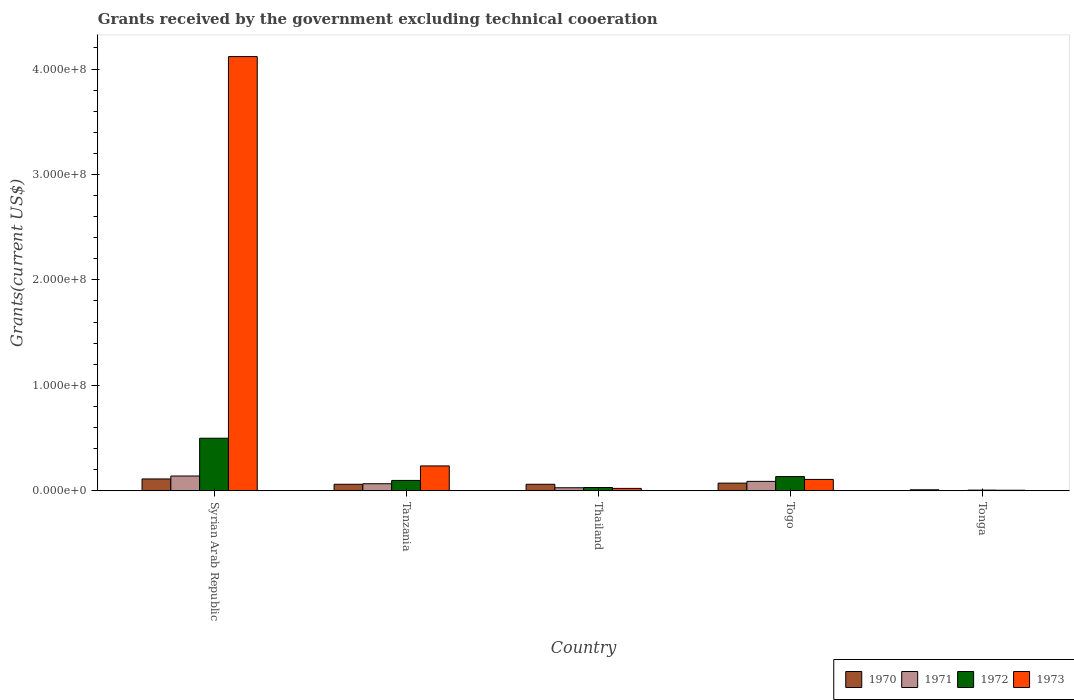How many bars are there on the 1st tick from the right?
Provide a short and direct response. 4. What is the label of the 4th group of bars from the left?
Keep it short and to the point. Togo. What is the total grants received by the government in 1970 in Thailand?
Your answer should be compact. 6.18e+06. Across all countries, what is the maximum total grants received by the government in 1972?
Provide a succinct answer. 4.98e+07. Across all countries, what is the minimum total grants received by the government in 1970?
Provide a succinct answer. 9.50e+05. In which country was the total grants received by the government in 1972 maximum?
Your response must be concise. Syrian Arab Republic. In which country was the total grants received by the government in 1970 minimum?
Your answer should be compact. Tonga. What is the total total grants received by the government in 1972 in the graph?
Provide a short and direct response. 7.69e+07. What is the difference between the total grants received by the government in 1971 in Tanzania and that in Togo?
Give a very brief answer. -2.25e+06. What is the difference between the total grants received by the government in 1972 in Tanzania and the total grants received by the government in 1973 in Thailand?
Provide a succinct answer. 7.55e+06. What is the average total grants received by the government in 1972 per country?
Provide a succinct answer. 1.54e+07. What is the difference between the total grants received by the government of/in 1972 and total grants received by the government of/in 1973 in Tanzania?
Your answer should be compact. -1.38e+07. In how many countries, is the total grants received by the government in 1971 greater than 200000000 US$?
Make the answer very short. 0. What is the ratio of the total grants received by the government in 1971 in Thailand to that in Togo?
Keep it short and to the point. 0.32. Is the difference between the total grants received by the government in 1972 in Thailand and Togo greater than the difference between the total grants received by the government in 1973 in Thailand and Togo?
Give a very brief answer. No. What is the difference between the highest and the second highest total grants received by the government in 1972?
Make the answer very short. 3.64e+07. What is the difference between the highest and the lowest total grants received by the government in 1973?
Make the answer very short. 4.11e+08. Is it the case that in every country, the sum of the total grants received by the government in 1973 and total grants received by the government in 1972 is greater than the sum of total grants received by the government in 1971 and total grants received by the government in 1970?
Provide a succinct answer. No. What does the 4th bar from the left in Syrian Arab Republic represents?
Your response must be concise. 1973. What does the 2nd bar from the right in Tonga represents?
Provide a succinct answer. 1972. Is it the case that in every country, the sum of the total grants received by the government in 1971 and total grants received by the government in 1970 is greater than the total grants received by the government in 1972?
Keep it short and to the point. No. How many bars are there?
Provide a succinct answer. 20. Are all the bars in the graph horizontal?
Make the answer very short. No. How many countries are there in the graph?
Your response must be concise. 5. Are the values on the major ticks of Y-axis written in scientific E-notation?
Keep it short and to the point. Yes. How are the legend labels stacked?
Your answer should be compact. Horizontal. What is the title of the graph?
Your answer should be compact. Grants received by the government excluding technical cooeration. What is the label or title of the X-axis?
Provide a short and direct response. Country. What is the label or title of the Y-axis?
Provide a short and direct response. Grants(current US$). What is the Grants(current US$) in 1970 in Syrian Arab Republic?
Give a very brief answer. 1.12e+07. What is the Grants(current US$) in 1971 in Syrian Arab Republic?
Your answer should be very brief. 1.40e+07. What is the Grants(current US$) of 1972 in Syrian Arab Republic?
Keep it short and to the point. 4.98e+07. What is the Grants(current US$) in 1973 in Syrian Arab Republic?
Your answer should be very brief. 4.12e+08. What is the Grants(current US$) of 1970 in Tanzania?
Ensure brevity in your answer.  6.17e+06. What is the Grants(current US$) in 1971 in Tanzania?
Give a very brief answer. 6.68e+06. What is the Grants(current US$) of 1972 in Tanzania?
Offer a very short reply. 9.82e+06. What is the Grants(current US$) in 1973 in Tanzania?
Your response must be concise. 2.36e+07. What is the Grants(current US$) in 1970 in Thailand?
Your response must be concise. 6.18e+06. What is the Grants(current US$) of 1971 in Thailand?
Your answer should be very brief. 2.88e+06. What is the Grants(current US$) of 1972 in Thailand?
Your response must be concise. 3.12e+06. What is the Grants(current US$) in 1973 in Thailand?
Your answer should be very brief. 2.27e+06. What is the Grants(current US$) in 1970 in Togo?
Provide a short and direct response. 7.26e+06. What is the Grants(current US$) of 1971 in Togo?
Your answer should be very brief. 8.93e+06. What is the Grants(current US$) in 1972 in Togo?
Your answer should be compact. 1.35e+07. What is the Grants(current US$) of 1973 in Togo?
Give a very brief answer. 1.08e+07. What is the Grants(current US$) in 1970 in Tonga?
Your answer should be very brief. 9.50e+05. What is the Grants(current US$) in 1972 in Tonga?
Offer a very short reply. 6.30e+05. What is the Grants(current US$) of 1973 in Tonga?
Provide a short and direct response. 5.10e+05. Across all countries, what is the maximum Grants(current US$) in 1970?
Give a very brief answer. 1.12e+07. Across all countries, what is the maximum Grants(current US$) of 1971?
Provide a succinct answer. 1.40e+07. Across all countries, what is the maximum Grants(current US$) in 1972?
Give a very brief answer. 4.98e+07. Across all countries, what is the maximum Grants(current US$) in 1973?
Provide a short and direct response. 4.12e+08. Across all countries, what is the minimum Grants(current US$) in 1970?
Provide a short and direct response. 9.50e+05. Across all countries, what is the minimum Grants(current US$) in 1972?
Make the answer very short. 6.30e+05. Across all countries, what is the minimum Grants(current US$) in 1973?
Your response must be concise. 5.10e+05. What is the total Grants(current US$) of 1970 in the graph?
Make the answer very short. 3.18e+07. What is the total Grants(current US$) of 1971 in the graph?
Offer a terse response. 3.28e+07. What is the total Grants(current US$) in 1972 in the graph?
Offer a very short reply. 7.69e+07. What is the total Grants(current US$) of 1973 in the graph?
Offer a terse response. 4.49e+08. What is the difference between the Grants(current US$) in 1970 in Syrian Arab Republic and that in Tanzania?
Provide a succinct answer. 5.06e+06. What is the difference between the Grants(current US$) of 1971 in Syrian Arab Republic and that in Tanzania?
Your answer should be very brief. 7.33e+06. What is the difference between the Grants(current US$) of 1972 in Syrian Arab Republic and that in Tanzania?
Your answer should be compact. 4.00e+07. What is the difference between the Grants(current US$) of 1973 in Syrian Arab Republic and that in Tanzania?
Offer a terse response. 3.88e+08. What is the difference between the Grants(current US$) of 1970 in Syrian Arab Republic and that in Thailand?
Your answer should be very brief. 5.05e+06. What is the difference between the Grants(current US$) in 1971 in Syrian Arab Republic and that in Thailand?
Offer a terse response. 1.11e+07. What is the difference between the Grants(current US$) of 1972 in Syrian Arab Republic and that in Thailand?
Give a very brief answer. 4.67e+07. What is the difference between the Grants(current US$) in 1973 in Syrian Arab Republic and that in Thailand?
Provide a short and direct response. 4.10e+08. What is the difference between the Grants(current US$) of 1970 in Syrian Arab Republic and that in Togo?
Give a very brief answer. 3.97e+06. What is the difference between the Grants(current US$) of 1971 in Syrian Arab Republic and that in Togo?
Provide a short and direct response. 5.08e+06. What is the difference between the Grants(current US$) of 1972 in Syrian Arab Republic and that in Togo?
Keep it short and to the point. 3.64e+07. What is the difference between the Grants(current US$) of 1973 in Syrian Arab Republic and that in Togo?
Provide a succinct answer. 4.01e+08. What is the difference between the Grants(current US$) in 1970 in Syrian Arab Republic and that in Tonga?
Your answer should be very brief. 1.03e+07. What is the difference between the Grants(current US$) in 1971 in Syrian Arab Republic and that in Tonga?
Provide a succinct answer. 1.38e+07. What is the difference between the Grants(current US$) in 1972 in Syrian Arab Republic and that in Tonga?
Provide a short and direct response. 4.92e+07. What is the difference between the Grants(current US$) of 1973 in Syrian Arab Republic and that in Tonga?
Keep it short and to the point. 4.11e+08. What is the difference between the Grants(current US$) of 1970 in Tanzania and that in Thailand?
Your answer should be very brief. -10000. What is the difference between the Grants(current US$) in 1971 in Tanzania and that in Thailand?
Offer a terse response. 3.80e+06. What is the difference between the Grants(current US$) in 1972 in Tanzania and that in Thailand?
Give a very brief answer. 6.70e+06. What is the difference between the Grants(current US$) of 1973 in Tanzania and that in Thailand?
Ensure brevity in your answer.  2.13e+07. What is the difference between the Grants(current US$) of 1970 in Tanzania and that in Togo?
Provide a succinct answer. -1.09e+06. What is the difference between the Grants(current US$) in 1971 in Tanzania and that in Togo?
Offer a very short reply. -2.25e+06. What is the difference between the Grants(current US$) of 1972 in Tanzania and that in Togo?
Your response must be concise. -3.66e+06. What is the difference between the Grants(current US$) in 1973 in Tanzania and that in Togo?
Keep it short and to the point. 1.28e+07. What is the difference between the Grants(current US$) in 1970 in Tanzania and that in Tonga?
Offer a terse response. 5.22e+06. What is the difference between the Grants(current US$) of 1971 in Tanzania and that in Tonga?
Make the answer very short. 6.42e+06. What is the difference between the Grants(current US$) of 1972 in Tanzania and that in Tonga?
Offer a very short reply. 9.19e+06. What is the difference between the Grants(current US$) in 1973 in Tanzania and that in Tonga?
Your answer should be compact. 2.31e+07. What is the difference between the Grants(current US$) of 1970 in Thailand and that in Togo?
Your answer should be compact. -1.08e+06. What is the difference between the Grants(current US$) in 1971 in Thailand and that in Togo?
Make the answer very short. -6.05e+06. What is the difference between the Grants(current US$) of 1972 in Thailand and that in Togo?
Make the answer very short. -1.04e+07. What is the difference between the Grants(current US$) of 1973 in Thailand and that in Togo?
Your response must be concise. -8.52e+06. What is the difference between the Grants(current US$) in 1970 in Thailand and that in Tonga?
Your answer should be compact. 5.23e+06. What is the difference between the Grants(current US$) in 1971 in Thailand and that in Tonga?
Provide a succinct answer. 2.62e+06. What is the difference between the Grants(current US$) in 1972 in Thailand and that in Tonga?
Provide a short and direct response. 2.49e+06. What is the difference between the Grants(current US$) in 1973 in Thailand and that in Tonga?
Keep it short and to the point. 1.76e+06. What is the difference between the Grants(current US$) in 1970 in Togo and that in Tonga?
Keep it short and to the point. 6.31e+06. What is the difference between the Grants(current US$) in 1971 in Togo and that in Tonga?
Keep it short and to the point. 8.67e+06. What is the difference between the Grants(current US$) in 1972 in Togo and that in Tonga?
Your response must be concise. 1.28e+07. What is the difference between the Grants(current US$) of 1973 in Togo and that in Tonga?
Keep it short and to the point. 1.03e+07. What is the difference between the Grants(current US$) of 1970 in Syrian Arab Republic and the Grants(current US$) of 1971 in Tanzania?
Offer a terse response. 4.55e+06. What is the difference between the Grants(current US$) in 1970 in Syrian Arab Republic and the Grants(current US$) in 1972 in Tanzania?
Provide a short and direct response. 1.41e+06. What is the difference between the Grants(current US$) of 1970 in Syrian Arab Republic and the Grants(current US$) of 1973 in Tanzania?
Provide a succinct answer. -1.24e+07. What is the difference between the Grants(current US$) in 1971 in Syrian Arab Republic and the Grants(current US$) in 1972 in Tanzania?
Your answer should be compact. 4.19e+06. What is the difference between the Grants(current US$) of 1971 in Syrian Arab Republic and the Grants(current US$) of 1973 in Tanzania?
Provide a short and direct response. -9.57e+06. What is the difference between the Grants(current US$) in 1972 in Syrian Arab Republic and the Grants(current US$) in 1973 in Tanzania?
Provide a short and direct response. 2.63e+07. What is the difference between the Grants(current US$) in 1970 in Syrian Arab Republic and the Grants(current US$) in 1971 in Thailand?
Your answer should be compact. 8.35e+06. What is the difference between the Grants(current US$) of 1970 in Syrian Arab Republic and the Grants(current US$) of 1972 in Thailand?
Provide a short and direct response. 8.11e+06. What is the difference between the Grants(current US$) of 1970 in Syrian Arab Republic and the Grants(current US$) of 1973 in Thailand?
Provide a succinct answer. 8.96e+06. What is the difference between the Grants(current US$) in 1971 in Syrian Arab Republic and the Grants(current US$) in 1972 in Thailand?
Make the answer very short. 1.09e+07. What is the difference between the Grants(current US$) in 1971 in Syrian Arab Republic and the Grants(current US$) in 1973 in Thailand?
Give a very brief answer. 1.17e+07. What is the difference between the Grants(current US$) in 1972 in Syrian Arab Republic and the Grants(current US$) in 1973 in Thailand?
Provide a succinct answer. 4.76e+07. What is the difference between the Grants(current US$) of 1970 in Syrian Arab Republic and the Grants(current US$) of 1971 in Togo?
Offer a very short reply. 2.30e+06. What is the difference between the Grants(current US$) of 1970 in Syrian Arab Republic and the Grants(current US$) of 1972 in Togo?
Provide a succinct answer. -2.25e+06. What is the difference between the Grants(current US$) of 1970 in Syrian Arab Republic and the Grants(current US$) of 1973 in Togo?
Keep it short and to the point. 4.40e+05. What is the difference between the Grants(current US$) of 1971 in Syrian Arab Republic and the Grants(current US$) of 1972 in Togo?
Provide a succinct answer. 5.30e+05. What is the difference between the Grants(current US$) of 1971 in Syrian Arab Republic and the Grants(current US$) of 1973 in Togo?
Offer a very short reply. 3.22e+06. What is the difference between the Grants(current US$) of 1972 in Syrian Arab Republic and the Grants(current US$) of 1973 in Togo?
Your answer should be very brief. 3.91e+07. What is the difference between the Grants(current US$) in 1970 in Syrian Arab Republic and the Grants(current US$) in 1971 in Tonga?
Give a very brief answer. 1.10e+07. What is the difference between the Grants(current US$) in 1970 in Syrian Arab Republic and the Grants(current US$) in 1972 in Tonga?
Your response must be concise. 1.06e+07. What is the difference between the Grants(current US$) of 1970 in Syrian Arab Republic and the Grants(current US$) of 1973 in Tonga?
Your response must be concise. 1.07e+07. What is the difference between the Grants(current US$) of 1971 in Syrian Arab Republic and the Grants(current US$) of 1972 in Tonga?
Give a very brief answer. 1.34e+07. What is the difference between the Grants(current US$) of 1971 in Syrian Arab Republic and the Grants(current US$) of 1973 in Tonga?
Provide a succinct answer. 1.35e+07. What is the difference between the Grants(current US$) of 1972 in Syrian Arab Republic and the Grants(current US$) of 1973 in Tonga?
Keep it short and to the point. 4.93e+07. What is the difference between the Grants(current US$) of 1970 in Tanzania and the Grants(current US$) of 1971 in Thailand?
Offer a very short reply. 3.29e+06. What is the difference between the Grants(current US$) of 1970 in Tanzania and the Grants(current US$) of 1972 in Thailand?
Offer a very short reply. 3.05e+06. What is the difference between the Grants(current US$) in 1970 in Tanzania and the Grants(current US$) in 1973 in Thailand?
Provide a short and direct response. 3.90e+06. What is the difference between the Grants(current US$) of 1971 in Tanzania and the Grants(current US$) of 1972 in Thailand?
Your answer should be very brief. 3.56e+06. What is the difference between the Grants(current US$) of 1971 in Tanzania and the Grants(current US$) of 1973 in Thailand?
Give a very brief answer. 4.41e+06. What is the difference between the Grants(current US$) of 1972 in Tanzania and the Grants(current US$) of 1973 in Thailand?
Your response must be concise. 7.55e+06. What is the difference between the Grants(current US$) in 1970 in Tanzania and the Grants(current US$) in 1971 in Togo?
Your answer should be very brief. -2.76e+06. What is the difference between the Grants(current US$) of 1970 in Tanzania and the Grants(current US$) of 1972 in Togo?
Ensure brevity in your answer.  -7.31e+06. What is the difference between the Grants(current US$) of 1970 in Tanzania and the Grants(current US$) of 1973 in Togo?
Provide a succinct answer. -4.62e+06. What is the difference between the Grants(current US$) of 1971 in Tanzania and the Grants(current US$) of 1972 in Togo?
Offer a terse response. -6.80e+06. What is the difference between the Grants(current US$) in 1971 in Tanzania and the Grants(current US$) in 1973 in Togo?
Keep it short and to the point. -4.11e+06. What is the difference between the Grants(current US$) in 1972 in Tanzania and the Grants(current US$) in 1973 in Togo?
Your answer should be very brief. -9.70e+05. What is the difference between the Grants(current US$) of 1970 in Tanzania and the Grants(current US$) of 1971 in Tonga?
Provide a short and direct response. 5.91e+06. What is the difference between the Grants(current US$) of 1970 in Tanzania and the Grants(current US$) of 1972 in Tonga?
Ensure brevity in your answer.  5.54e+06. What is the difference between the Grants(current US$) of 1970 in Tanzania and the Grants(current US$) of 1973 in Tonga?
Keep it short and to the point. 5.66e+06. What is the difference between the Grants(current US$) in 1971 in Tanzania and the Grants(current US$) in 1972 in Tonga?
Give a very brief answer. 6.05e+06. What is the difference between the Grants(current US$) in 1971 in Tanzania and the Grants(current US$) in 1973 in Tonga?
Make the answer very short. 6.17e+06. What is the difference between the Grants(current US$) of 1972 in Tanzania and the Grants(current US$) of 1973 in Tonga?
Your answer should be very brief. 9.31e+06. What is the difference between the Grants(current US$) in 1970 in Thailand and the Grants(current US$) in 1971 in Togo?
Offer a terse response. -2.75e+06. What is the difference between the Grants(current US$) of 1970 in Thailand and the Grants(current US$) of 1972 in Togo?
Your response must be concise. -7.30e+06. What is the difference between the Grants(current US$) in 1970 in Thailand and the Grants(current US$) in 1973 in Togo?
Make the answer very short. -4.61e+06. What is the difference between the Grants(current US$) of 1971 in Thailand and the Grants(current US$) of 1972 in Togo?
Your response must be concise. -1.06e+07. What is the difference between the Grants(current US$) of 1971 in Thailand and the Grants(current US$) of 1973 in Togo?
Keep it short and to the point. -7.91e+06. What is the difference between the Grants(current US$) in 1972 in Thailand and the Grants(current US$) in 1973 in Togo?
Your response must be concise. -7.67e+06. What is the difference between the Grants(current US$) in 1970 in Thailand and the Grants(current US$) in 1971 in Tonga?
Your response must be concise. 5.92e+06. What is the difference between the Grants(current US$) in 1970 in Thailand and the Grants(current US$) in 1972 in Tonga?
Make the answer very short. 5.55e+06. What is the difference between the Grants(current US$) in 1970 in Thailand and the Grants(current US$) in 1973 in Tonga?
Offer a very short reply. 5.67e+06. What is the difference between the Grants(current US$) in 1971 in Thailand and the Grants(current US$) in 1972 in Tonga?
Give a very brief answer. 2.25e+06. What is the difference between the Grants(current US$) of 1971 in Thailand and the Grants(current US$) of 1973 in Tonga?
Your answer should be compact. 2.37e+06. What is the difference between the Grants(current US$) in 1972 in Thailand and the Grants(current US$) in 1973 in Tonga?
Your answer should be compact. 2.61e+06. What is the difference between the Grants(current US$) in 1970 in Togo and the Grants(current US$) in 1972 in Tonga?
Your answer should be compact. 6.63e+06. What is the difference between the Grants(current US$) of 1970 in Togo and the Grants(current US$) of 1973 in Tonga?
Give a very brief answer. 6.75e+06. What is the difference between the Grants(current US$) of 1971 in Togo and the Grants(current US$) of 1972 in Tonga?
Provide a succinct answer. 8.30e+06. What is the difference between the Grants(current US$) in 1971 in Togo and the Grants(current US$) in 1973 in Tonga?
Offer a very short reply. 8.42e+06. What is the difference between the Grants(current US$) of 1972 in Togo and the Grants(current US$) of 1973 in Tonga?
Offer a terse response. 1.30e+07. What is the average Grants(current US$) in 1970 per country?
Make the answer very short. 6.36e+06. What is the average Grants(current US$) in 1971 per country?
Make the answer very short. 6.55e+06. What is the average Grants(current US$) in 1972 per country?
Give a very brief answer. 1.54e+07. What is the average Grants(current US$) of 1973 per country?
Provide a short and direct response. 8.98e+07. What is the difference between the Grants(current US$) in 1970 and Grants(current US$) in 1971 in Syrian Arab Republic?
Give a very brief answer. -2.78e+06. What is the difference between the Grants(current US$) of 1970 and Grants(current US$) of 1972 in Syrian Arab Republic?
Provide a short and direct response. -3.86e+07. What is the difference between the Grants(current US$) of 1970 and Grants(current US$) of 1973 in Syrian Arab Republic?
Your answer should be very brief. -4.01e+08. What is the difference between the Grants(current US$) in 1971 and Grants(current US$) in 1972 in Syrian Arab Republic?
Provide a short and direct response. -3.58e+07. What is the difference between the Grants(current US$) of 1971 and Grants(current US$) of 1973 in Syrian Arab Republic?
Keep it short and to the point. -3.98e+08. What is the difference between the Grants(current US$) of 1972 and Grants(current US$) of 1973 in Syrian Arab Republic?
Your response must be concise. -3.62e+08. What is the difference between the Grants(current US$) in 1970 and Grants(current US$) in 1971 in Tanzania?
Your response must be concise. -5.10e+05. What is the difference between the Grants(current US$) of 1970 and Grants(current US$) of 1972 in Tanzania?
Keep it short and to the point. -3.65e+06. What is the difference between the Grants(current US$) of 1970 and Grants(current US$) of 1973 in Tanzania?
Your response must be concise. -1.74e+07. What is the difference between the Grants(current US$) in 1971 and Grants(current US$) in 1972 in Tanzania?
Ensure brevity in your answer.  -3.14e+06. What is the difference between the Grants(current US$) of 1971 and Grants(current US$) of 1973 in Tanzania?
Offer a terse response. -1.69e+07. What is the difference between the Grants(current US$) in 1972 and Grants(current US$) in 1973 in Tanzania?
Give a very brief answer. -1.38e+07. What is the difference between the Grants(current US$) in 1970 and Grants(current US$) in 1971 in Thailand?
Provide a succinct answer. 3.30e+06. What is the difference between the Grants(current US$) in 1970 and Grants(current US$) in 1972 in Thailand?
Your response must be concise. 3.06e+06. What is the difference between the Grants(current US$) in 1970 and Grants(current US$) in 1973 in Thailand?
Make the answer very short. 3.91e+06. What is the difference between the Grants(current US$) in 1971 and Grants(current US$) in 1972 in Thailand?
Your answer should be compact. -2.40e+05. What is the difference between the Grants(current US$) in 1972 and Grants(current US$) in 1973 in Thailand?
Give a very brief answer. 8.50e+05. What is the difference between the Grants(current US$) in 1970 and Grants(current US$) in 1971 in Togo?
Provide a short and direct response. -1.67e+06. What is the difference between the Grants(current US$) of 1970 and Grants(current US$) of 1972 in Togo?
Your answer should be compact. -6.22e+06. What is the difference between the Grants(current US$) of 1970 and Grants(current US$) of 1973 in Togo?
Make the answer very short. -3.53e+06. What is the difference between the Grants(current US$) in 1971 and Grants(current US$) in 1972 in Togo?
Offer a very short reply. -4.55e+06. What is the difference between the Grants(current US$) of 1971 and Grants(current US$) of 1973 in Togo?
Your answer should be very brief. -1.86e+06. What is the difference between the Grants(current US$) of 1972 and Grants(current US$) of 1973 in Togo?
Give a very brief answer. 2.69e+06. What is the difference between the Grants(current US$) of 1970 and Grants(current US$) of 1971 in Tonga?
Offer a terse response. 6.90e+05. What is the difference between the Grants(current US$) in 1970 and Grants(current US$) in 1973 in Tonga?
Keep it short and to the point. 4.40e+05. What is the difference between the Grants(current US$) of 1971 and Grants(current US$) of 1972 in Tonga?
Your answer should be very brief. -3.70e+05. What is the difference between the Grants(current US$) of 1972 and Grants(current US$) of 1973 in Tonga?
Your answer should be very brief. 1.20e+05. What is the ratio of the Grants(current US$) of 1970 in Syrian Arab Republic to that in Tanzania?
Provide a succinct answer. 1.82. What is the ratio of the Grants(current US$) of 1971 in Syrian Arab Republic to that in Tanzania?
Your answer should be compact. 2.1. What is the ratio of the Grants(current US$) in 1972 in Syrian Arab Republic to that in Tanzania?
Keep it short and to the point. 5.08. What is the ratio of the Grants(current US$) of 1973 in Syrian Arab Republic to that in Tanzania?
Keep it short and to the point. 17.46. What is the ratio of the Grants(current US$) in 1970 in Syrian Arab Republic to that in Thailand?
Make the answer very short. 1.82. What is the ratio of the Grants(current US$) in 1971 in Syrian Arab Republic to that in Thailand?
Provide a short and direct response. 4.86. What is the ratio of the Grants(current US$) in 1972 in Syrian Arab Republic to that in Thailand?
Offer a terse response. 15.98. What is the ratio of the Grants(current US$) in 1973 in Syrian Arab Republic to that in Thailand?
Give a very brief answer. 181.41. What is the ratio of the Grants(current US$) of 1970 in Syrian Arab Republic to that in Togo?
Ensure brevity in your answer.  1.55. What is the ratio of the Grants(current US$) in 1971 in Syrian Arab Republic to that in Togo?
Your answer should be very brief. 1.57. What is the ratio of the Grants(current US$) of 1972 in Syrian Arab Republic to that in Togo?
Give a very brief answer. 3.7. What is the ratio of the Grants(current US$) of 1973 in Syrian Arab Republic to that in Togo?
Your answer should be compact. 38.16. What is the ratio of the Grants(current US$) of 1970 in Syrian Arab Republic to that in Tonga?
Provide a succinct answer. 11.82. What is the ratio of the Grants(current US$) in 1971 in Syrian Arab Republic to that in Tonga?
Your response must be concise. 53.88. What is the ratio of the Grants(current US$) of 1972 in Syrian Arab Republic to that in Tonga?
Keep it short and to the point. 79.13. What is the ratio of the Grants(current US$) of 1973 in Syrian Arab Republic to that in Tonga?
Your answer should be very brief. 807.45. What is the ratio of the Grants(current US$) of 1971 in Tanzania to that in Thailand?
Offer a very short reply. 2.32. What is the ratio of the Grants(current US$) in 1972 in Tanzania to that in Thailand?
Your response must be concise. 3.15. What is the ratio of the Grants(current US$) in 1973 in Tanzania to that in Thailand?
Your response must be concise. 10.39. What is the ratio of the Grants(current US$) of 1970 in Tanzania to that in Togo?
Your answer should be very brief. 0.85. What is the ratio of the Grants(current US$) in 1971 in Tanzania to that in Togo?
Provide a short and direct response. 0.75. What is the ratio of the Grants(current US$) of 1972 in Tanzania to that in Togo?
Provide a short and direct response. 0.73. What is the ratio of the Grants(current US$) of 1973 in Tanzania to that in Togo?
Keep it short and to the point. 2.19. What is the ratio of the Grants(current US$) in 1970 in Tanzania to that in Tonga?
Provide a succinct answer. 6.49. What is the ratio of the Grants(current US$) in 1971 in Tanzania to that in Tonga?
Your response must be concise. 25.69. What is the ratio of the Grants(current US$) in 1972 in Tanzania to that in Tonga?
Your answer should be compact. 15.59. What is the ratio of the Grants(current US$) of 1973 in Tanzania to that in Tonga?
Ensure brevity in your answer.  46.24. What is the ratio of the Grants(current US$) in 1970 in Thailand to that in Togo?
Give a very brief answer. 0.85. What is the ratio of the Grants(current US$) in 1971 in Thailand to that in Togo?
Provide a short and direct response. 0.32. What is the ratio of the Grants(current US$) of 1972 in Thailand to that in Togo?
Make the answer very short. 0.23. What is the ratio of the Grants(current US$) of 1973 in Thailand to that in Togo?
Give a very brief answer. 0.21. What is the ratio of the Grants(current US$) in 1970 in Thailand to that in Tonga?
Give a very brief answer. 6.51. What is the ratio of the Grants(current US$) of 1971 in Thailand to that in Tonga?
Offer a very short reply. 11.08. What is the ratio of the Grants(current US$) of 1972 in Thailand to that in Tonga?
Keep it short and to the point. 4.95. What is the ratio of the Grants(current US$) of 1973 in Thailand to that in Tonga?
Give a very brief answer. 4.45. What is the ratio of the Grants(current US$) in 1970 in Togo to that in Tonga?
Keep it short and to the point. 7.64. What is the ratio of the Grants(current US$) of 1971 in Togo to that in Tonga?
Offer a terse response. 34.35. What is the ratio of the Grants(current US$) in 1972 in Togo to that in Tonga?
Provide a succinct answer. 21.4. What is the ratio of the Grants(current US$) in 1973 in Togo to that in Tonga?
Ensure brevity in your answer.  21.16. What is the difference between the highest and the second highest Grants(current US$) of 1970?
Make the answer very short. 3.97e+06. What is the difference between the highest and the second highest Grants(current US$) in 1971?
Offer a very short reply. 5.08e+06. What is the difference between the highest and the second highest Grants(current US$) in 1972?
Keep it short and to the point. 3.64e+07. What is the difference between the highest and the second highest Grants(current US$) of 1973?
Your answer should be very brief. 3.88e+08. What is the difference between the highest and the lowest Grants(current US$) in 1970?
Your response must be concise. 1.03e+07. What is the difference between the highest and the lowest Grants(current US$) of 1971?
Your answer should be very brief. 1.38e+07. What is the difference between the highest and the lowest Grants(current US$) of 1972?
Ensure brevity in your answer.  4.92e+07. What is the difference between the highest and the lowest Grants(current US$) of 1973?
Ensure brevity in your answer.  4.11e+08. 